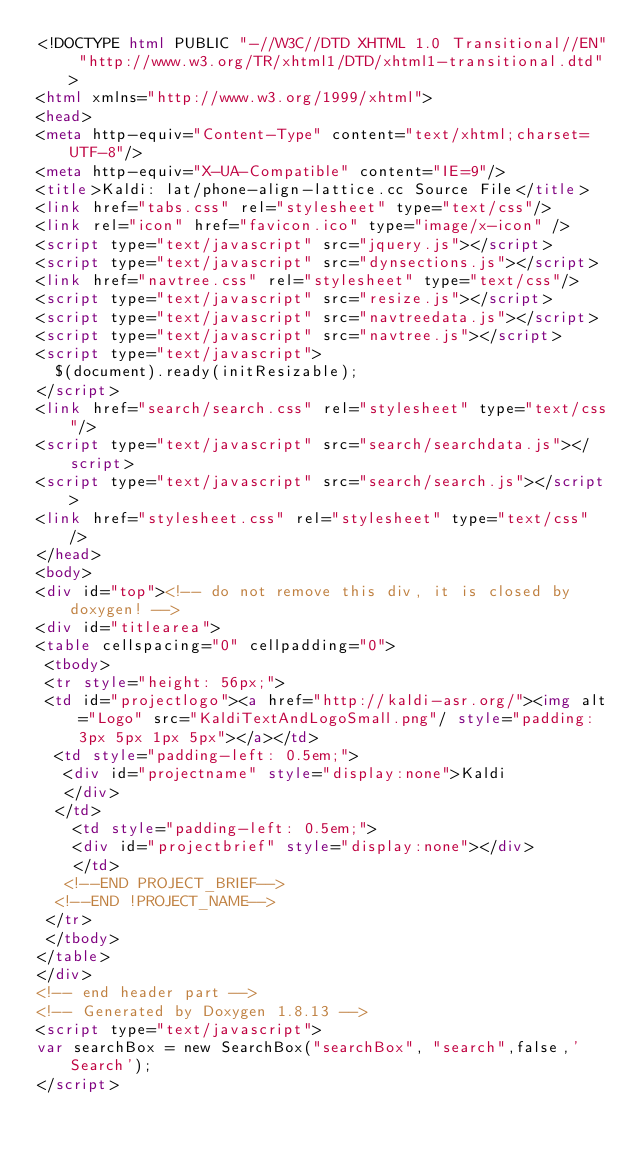Convert code to text. <code><loc_0><loc_0><loc_500><loc_500><_HTML_><!DOCTYPE html PUBLIC "-//W3C//DTD XHTML 1.0 Transitional//EN" "http://www.w3.org/TR/xhtml1/DTD/xhtml1-transitional.dtd">
<html xmlns="http://www.w3.org/1999/xhtml">
<head>
<meta http-equiv="Content-Type" content="text/xhtml;charset=UTF-8"/>
<meta http-equiv="X-UA-Compatible" content="IE=9"/>
<title>Kaldi: lat/phone-align-lattice.cc Source File</title>
<link href="tabs.css" rel="stylesheet" type="text/css"/>
<link rel="icon" href="favicon.ico" type="image/x-icon" />
<script type="text/javascript" src="jquery.js"></script>
<script type="text/javascript" src="dynsections.js"></script>
<link href="navtree.css" rel="stylesheet" type="text/css"/>
<script type="text/javascript" src="resize.js"></script>
<script type="text/javascript" src="navtreedata.js"></script>
<script type="text/javascript" src="navtree.js"></script>
<script type="text/javascript">
  $(document).ready(initResizable);
</script>
<link href="search/search.css" rel="stylesheet" type="text/css"/>
<script type="text/javascript" src="search/searchdata.js"></script>
<script type="text/javascript" src="search/search.js"></script>
<link href="stylesheet.css" rel="stylesheet" type="text/css" /> 
</head>
<body>
<div id="top"><!-- do not remove this div, it is closed by doxygen! -->
<div id="titlearea">
<table cellspacing="0" cellpadding="0">
 <tbody>
 <tr style="height: 56px;">
 <td id="projectlogo"><a href="http://kaldi-asr.org/"><img alt="Logo" src="KaldiTextAndLogoSmall.png"/ style="padding: 3px 5px 1px 5px"></a></td>
  <td style="padding-left: 0.5em;">
   <div id="projectname" style="display:none">Kaldi
   </div>
  </td>
    <td style="padding-left: 0.5em;">
    <div id="projectbrief" style="display:none"></div>
    </td>
   <!--END PROJECT_BRIEF-->
  <!--END !PROJECT_NAME-->
 </tr>
 </tbody>
</table>
</div>
<!-- end header part -->
<!-- Generated by Doxygen 1.8.13 -->
<script type="text/javascript">
var searchBox = new SearchBox("searchBox", "search",false,'Search');
</script></code> 